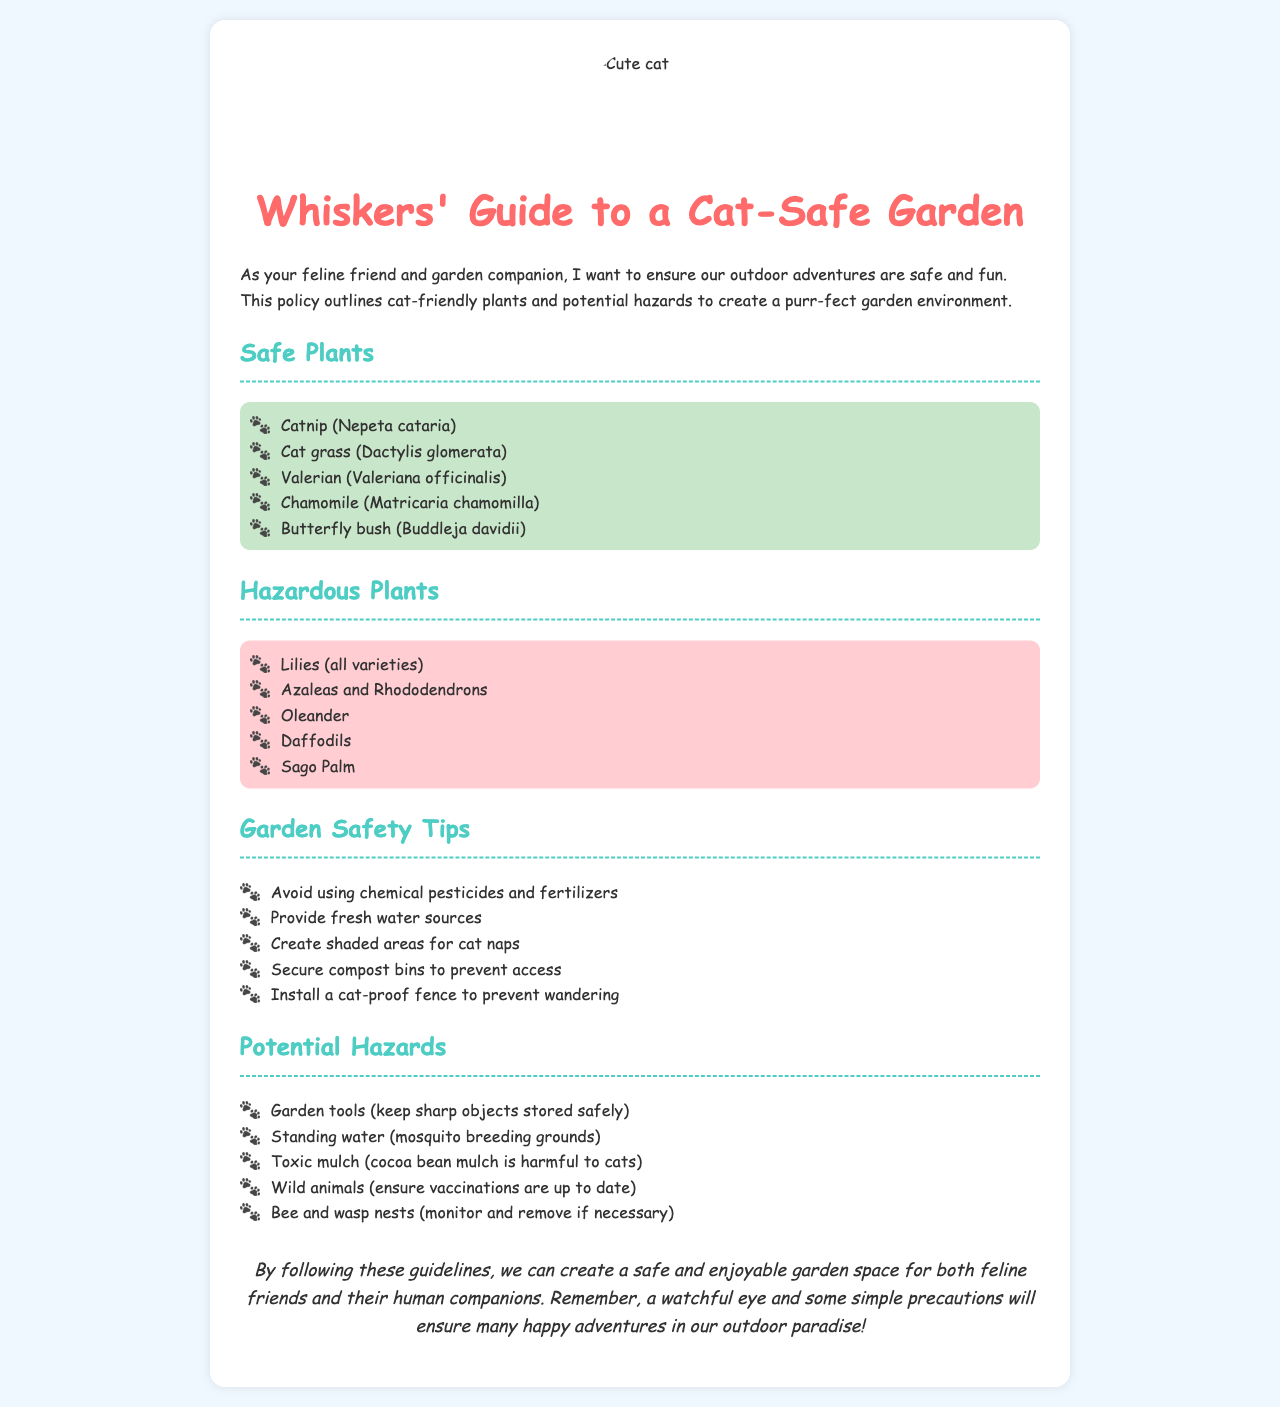what is the title of the policy document? The title of the policy document is indicated at the beginning and is "Whiskers' Guide to a Cat-Safe Garden."
Answer: Whiskers' Guide to a Cat-Safe Garden how many safe plants are listed? The document provides a specific number of plants in the "Safe Plants" section, which is five.
Answer: 5 name one hazardous plant mentioned in the document. The document lists several hazardous plants; one example is provided in the "Hazardous Plants" section.
Answer: Lilies what type of mulch is harmful to cats? The document specifically states that "cocoa bean mulch is harmful to cats."
Answer: cocoa bean mulch what is one of the garden safety tips? The garden safety tips section offers various suggestions, such as avoiding chemical pesticides and fertilizers.
Answer: Avoid using chemical pesticides and fertilizers why should garden tools be stored safely? The document mentions that sharp objects pose potential hazards, thus requiring safe storage.
Answer: To keep sharp objects stored safely how many total potential hazards are listed? The document counts and mentions five specific potential hazards in the corresponding section.
Answer: 5 what is suggested to prevent wandering? The document includes a specific measure in the garden safety tips to prevent wandering.
Answer: Install a cat-proof fence 